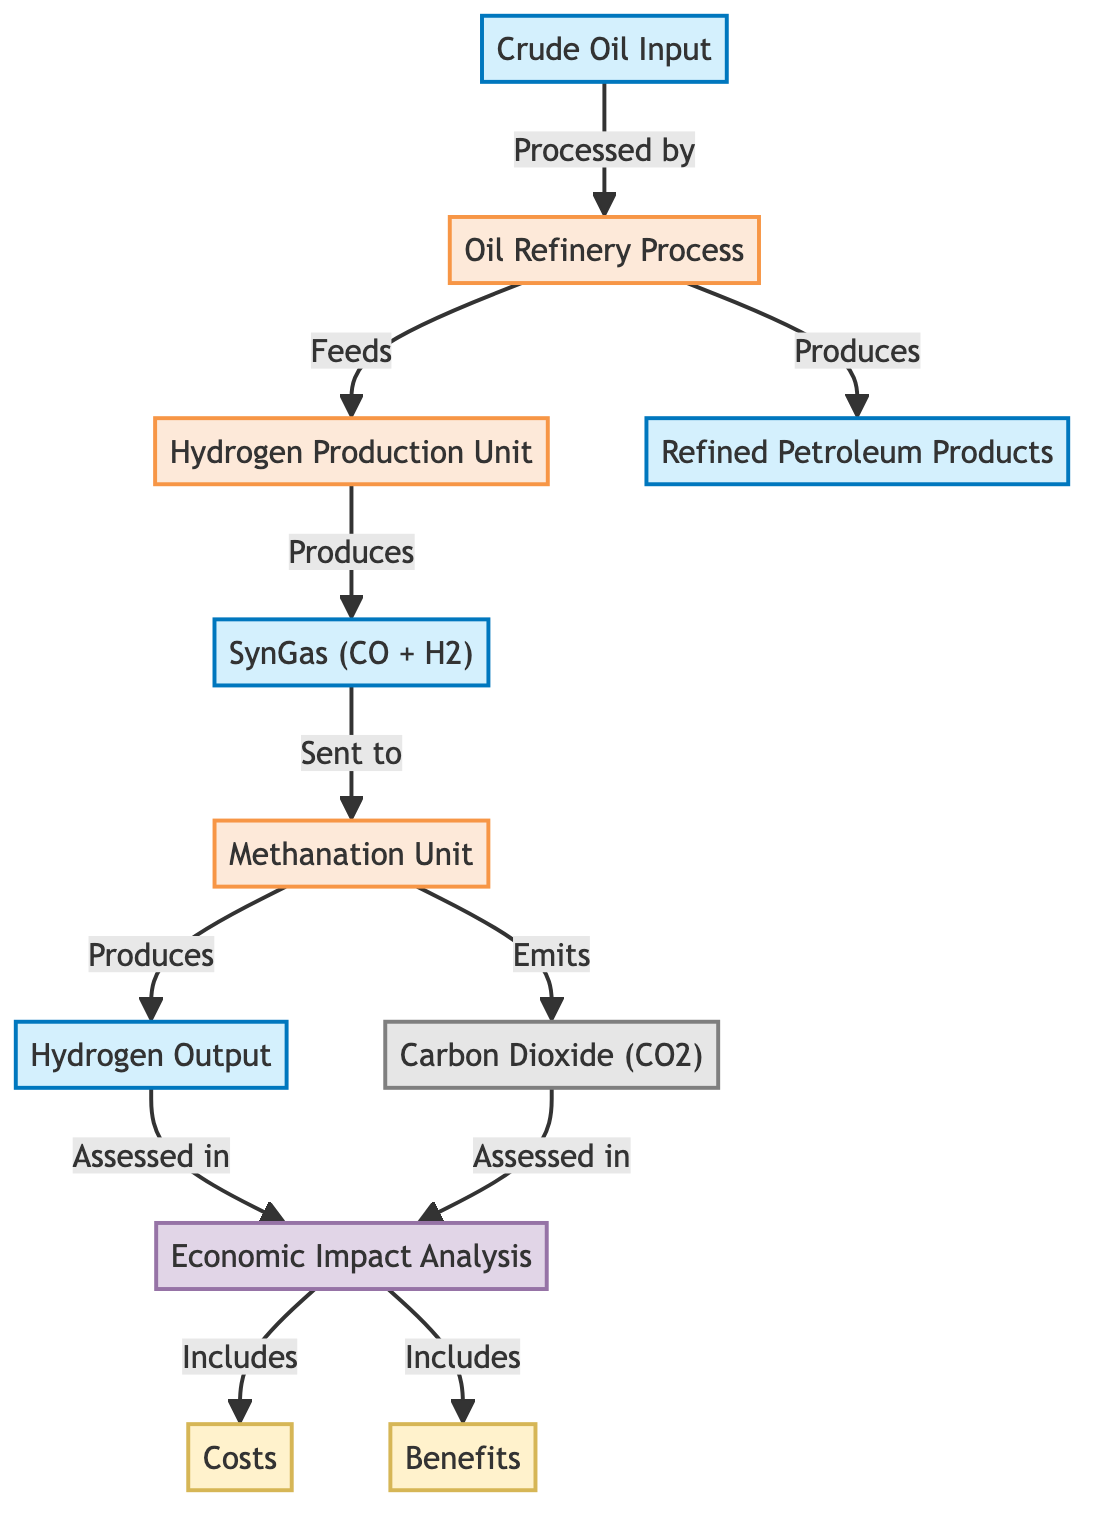What is the first input in the process? The first input node in the diagram is "Crude Oil Input." It is the starting point of the flow leading into the oil refinery process. Hence, it serves as the primary resource for the entire production process.
Answer: Crude Oil Input What does the oil refinery process produce? According to the diagram, the oil refinery process has an arrow indicating it "Produces" refined petroleum products. This clearly states the major output of the refinery stage in the process flow.
Answer: Refined Petroleum Products Which process unit feeds into the hydrogen production unit? In the diagram, there is an arrow depicting the flow from the "Oil Refinery Process" into the "Hydrogen Production Unit," indicating that the output from the refinery directly serves as an input for hydrogen production.
Answer: Oil Refinery Process How many total processes are outlined in the diagram? The diagram identifies four distinct processing units: "Oil Refinery Process," "Hydrogen Production Unit," "Methanation Unit," and one implicit count for economic impact analysis. Therefore, counting only the named processes yields a total of three distinct processes.
Answer: Three What are the two key components assessed in the economic impact analysis? The economic impact analysis in the diagram includes two elements: "Costs" and "Benefits." These are explicitly mentioned as part of the evaluation phase in the flow.
Answer: Costs and Benefits What type of gas does the methanation unit produce? The methanation unit is linked in the diagram with the output labeled "Hydrogen Output." Therefore, it directly conveys that the methanation unit's output is hydrogen.
Answer: Hydrogen Output What byproduct is emitted during the production process? The diagram specifies that the methanation unit "Emits" carbon dioxide as a byproduct. This indicates that CO2 is a secondary output resulting from the methanation process within the overall operations.
Answer: Carbon Dioxide How does hydrogen production affect the economic analysis? The diagram illustrates that hydrogen output is assessed in the economic impact analysis. This implies that both the production and economic viability of hydrogen integrally contribute to evaluating the economic factors.
Answer: Assessed in Economic Impact Which component sends syngas to the methanation unit? The flow diagram indicates that "SynGas (CO + H2)" is transported to the "Methanation Unit," meaning that syngas is the precursor fuel for hydrogen output in this process.
Answer: SynGas (CO + H2) 